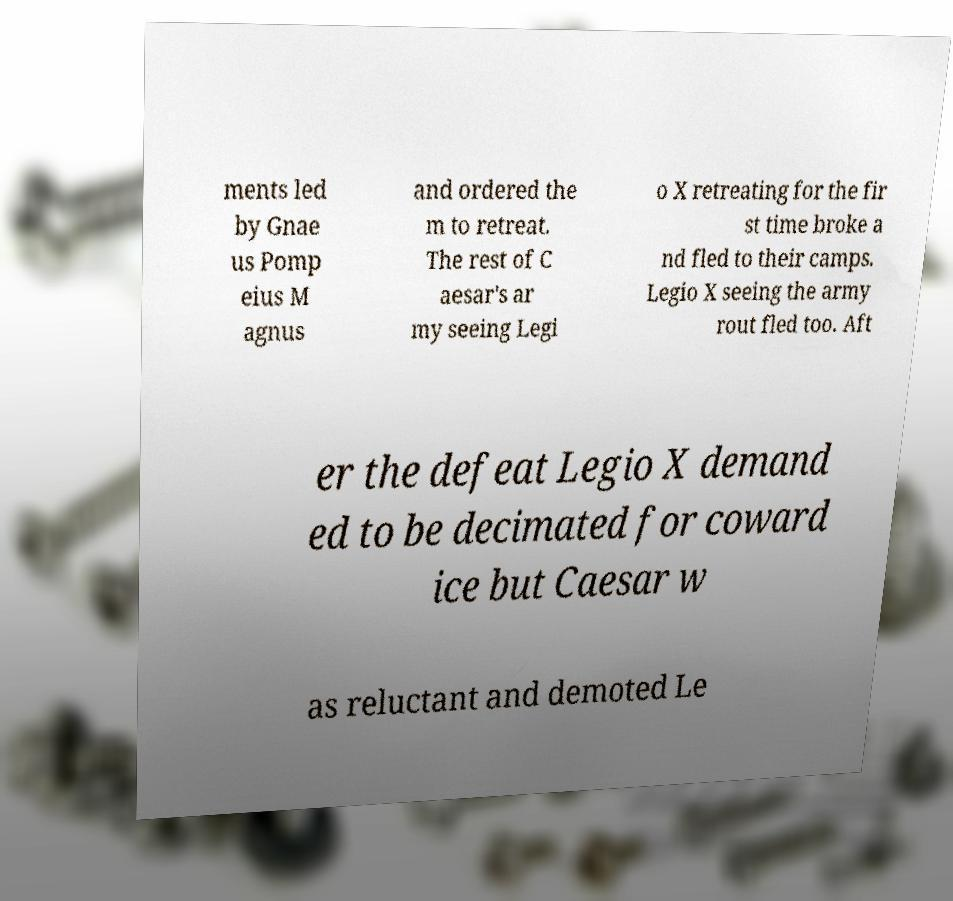Could you assist in decoding the text presented in this image and type it out clearly? ments led by Gnae us Pomp eius M agnus and ordered the m to retreat. The rest of C aesar's ar my seeing Legi o X retreating for the fir st time broke a nd fled to their camps. Legio X seeing the army rout fled too. Aft er the defeat Legio X demand ed to be decimated for coward ice but Caesar w as reluctant and demoted Le 